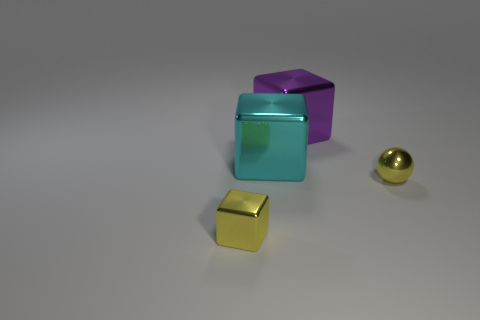There is a small metal thing that is on the right side of the purple metal object; what is its shape?
Provide a succinct answer. Sphere. Is the cyan object made of the same material as the yellow object to the left of the yellow shiny sphere?
Provide a short and direct response. Yes. How many other objects are there of the same shape as the large purple object?
Your answer should be compact. 2. Is the color of the metallic ball the same as the metal block that is in front of the tiny ball?
Make the answer very short. Yes. There is a metal thing that is right of the metallic cube that is behind the cyan thing; what shape is it?
Offer a very short reply. Sphere. The thing that is the same color as the tiny shiny ball is what size?
Provide a succinct answer. Small. There is a small object that is behind the small yellow cube; is its shape the same as the large cyan metal object?
Offer a terse response. No. Are there more purple metallic cubes right of the yellow metallic ball than large metal cubes that are on the left side of the purple metal object?
Offer a very short reply. No. How many yellow metal cubes are right of the yellow metallic thing on the left side of the metallic ball?
Your response must be concise. 0. What material is the cube that is the same color as the ball?
Your answer should be very brief. Metal. 